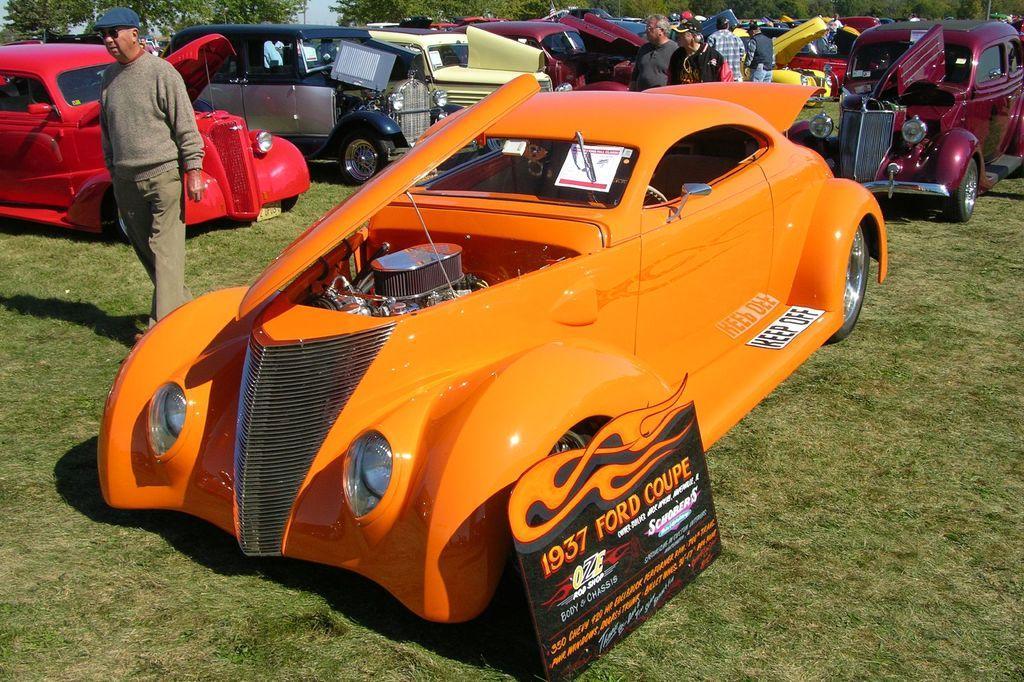Can you describe this image briefly? In the foreground of this image, there is a car and a board on the grass. Behind it, there are many cars on the grass and few people walking and standing on it. At the top, there are trees. 